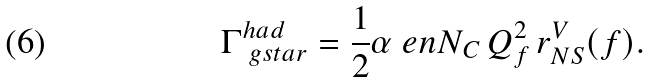Convert formula to latex. <formula><loc_0><loc_0><loc_500><loc_500>\Gamma ^ { h a d } _ { \ g s t a r } = \frac { 1 } { 2 } \alpha \ e n N _ { C } \, Q _ { f } ^ { 2 } \, r ^ { V } _ { N S } ( f ) .</formula> 